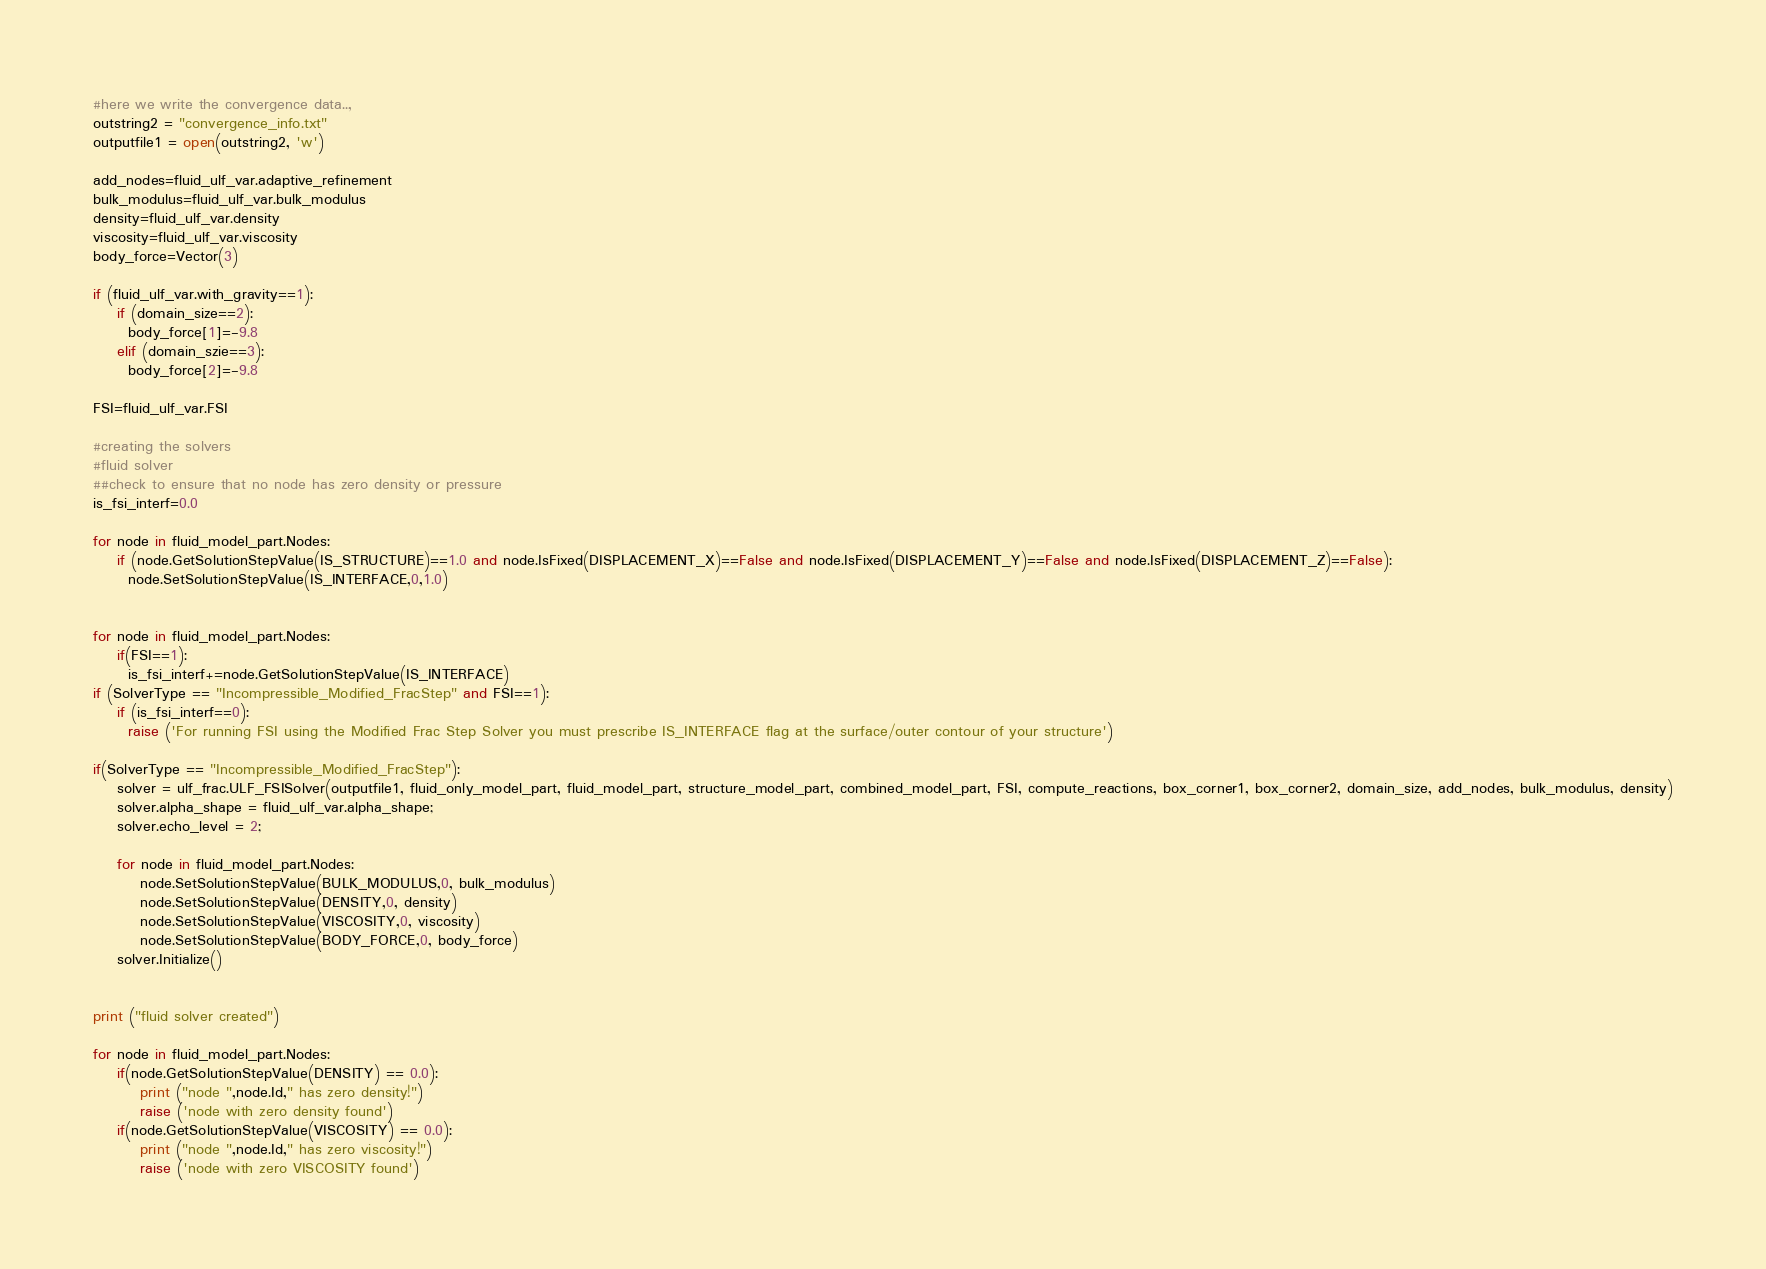Convert code to text. <code><loc_0><loc_0><loc_500><loc_500><_Python_>
#here we write the convergence data..,
outstring2 = "convergence_info.txt"
outputfile1 = open(outstring2, 'w')

add_nodes=fluid_ulf_var.adaptive_refinement
bulk_modulus=fluid_ulf_var.bulk_modulus
density=fluid_ulf_var.density
viscosity=fluid_ulf_var.viscosity
body_force=Vector(3)

if (fluid_ulf_var.with_gravity==1):
    if (domain_size==2):
      body_force[1]=-9.8
    elif (domain_szie==3):
      body_force[2]=-9.8

FSI=fluid_ulf_var.FSI

#creating the solvers
#fluid solver
##check to ensure that no node has zero density or pressure
is_fsi_interf=0.0

for node in fluid_model_part.Nodes:
    if (node.GetSolutionStepValue(IS_STRUCTURE)==1.0 and node.IsFixed(DISPLACEMENT_X)==False and node.IsFixed(DISPLACEMENT_Y)==False and node.IsFixed(DISPLACEMENT_Z)==False):
      node.SetSolutionStepValue(IS_INTERFACE,0,1.0)


for node in fluid_model_part.Nodes:
    if(FSI==1):
      is_fsi_interf+=node.GetSolutionStepValue(IS_INTERFACE)      
if (SolverType == "Incompressible_Modified_FracStep" and FSI==1):
    if (is_fsi_interf==0):
      raise ('For running FSI using the Modified Frac Step Solver you must prescribe IS_INTERFACE flag at the surface/outer contour of your structure')

if(SolverType == "Incompressible_Modified_FracStep"):    
    solver = ulf_frac.ULF_FSISolver(outputfile1, fluid_only_model_part, fluid_model_part, structure_model_part, combined_model_part, FSI, compute_reactions, box_corner1, box_corner2, domain_size, add_nodes, bulk_modulus, density)
    solver.alpha_shape = fluid_ulf_var.alpha_shape;
    solver.echo_level = 2;
    
    for node in fluid_model_part.Nodes:
        node.SetSolutionStepValue(BULK_MODULUS,0, bulk_modulus)
        node.SetSolutionStepValue(DENSITY,0, density)   
        node.SetSolutionStepValue(VISCOSITY,0, viscosity)   
        node.SetSolutionStepValue(BODY_FORCE,0, body_force)
    solver.Initialize()


print ("fluid solver created")

for node in fluid_model_part.Nodes:
    if(node.GetSolutionStepValue(DENSITY) == 0.0):
        print ("node ",node.Id," has zero density!")
        raise ('node with zero density found')
    if(node.GetSolutionStepValue(VISCOSITY) == 0.0):
        print ("node ",node.Id," has zero viscosity!")
        raise ('node with zero VISCOSITY found')    
</code> 